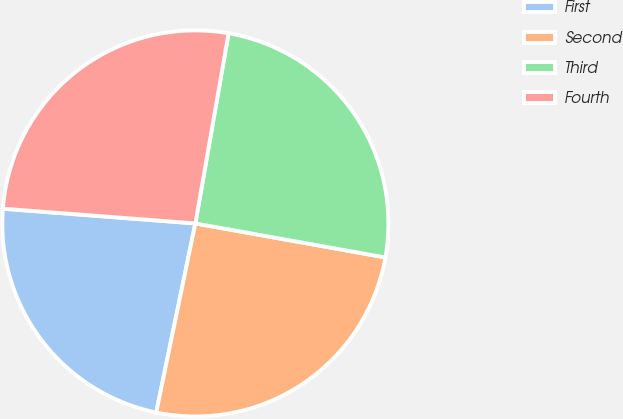Convert chart. <chart><loc_0><loc_0><loc_500><loc_500><pie_chart><fcel>First<fcel>Second<fcel>Third<fcel>Fourth<nl><fcel>22.97%<fcel>25.43%<fcel>25.07%<fcel>26.54%<nl></chart> 